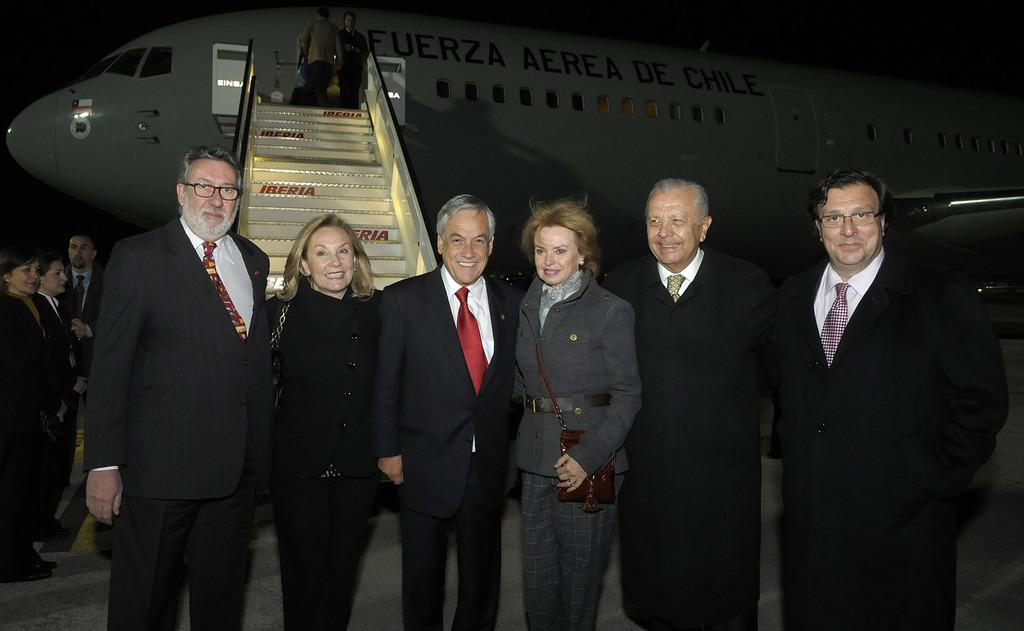How many people are in the image? There is a group of people in the image. Where are the people standing? The people are standing on a path. What is visible behind the people? There is an airplane behind the people. What architectural feature can be seen in the image? There are stairs visible in the image. What is the color of the background in the image? The background of the image is dark. What type of yam is being used as a prop by the people in the image? There is no yam present in the image, and the people are not using any props. What color is the mint in the image? There is no mint present in the image. 